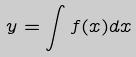<formula> <loc_0><loc_0><loc_500><loc_500>y = \int f ( x ) d x</formula> 